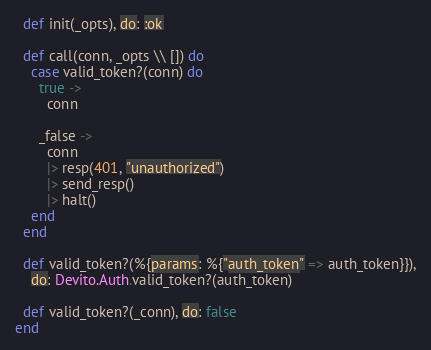Convert code to text. <code><loc_0><loc_0><loc_500><loc_500><_Elixir_>  def init(_opts), do: :ok

  def call(conn, _opts \\ []) do
    case valid_token?(conn) do
      true ->
        conn

      _false ->
        conn
        |> resp(401, "unauthorized")
        |> send_resp()
        |> halt()
    end
  end

  def valid_token?(%{params: %{"auth_token" => auth_token}}),
    do: Devito.Auth.valid_token?(auth_token)

  def valid_token?(_conn), do: false
end
</code> 